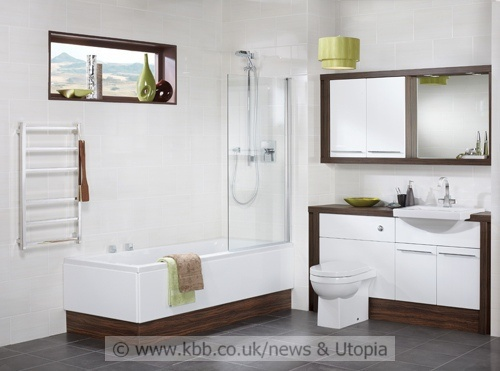Describe the objects in this image and their specific colors. I can see toilet in lightgray and darkgray tones, sink in lightgray, darkgray, gray, and black tones, vase in lightgray, olive, and beige tones, bowl in lightgray, olive, and black tones, and bowl in lightgray, tan, olive, beige, and black tones in this image. 